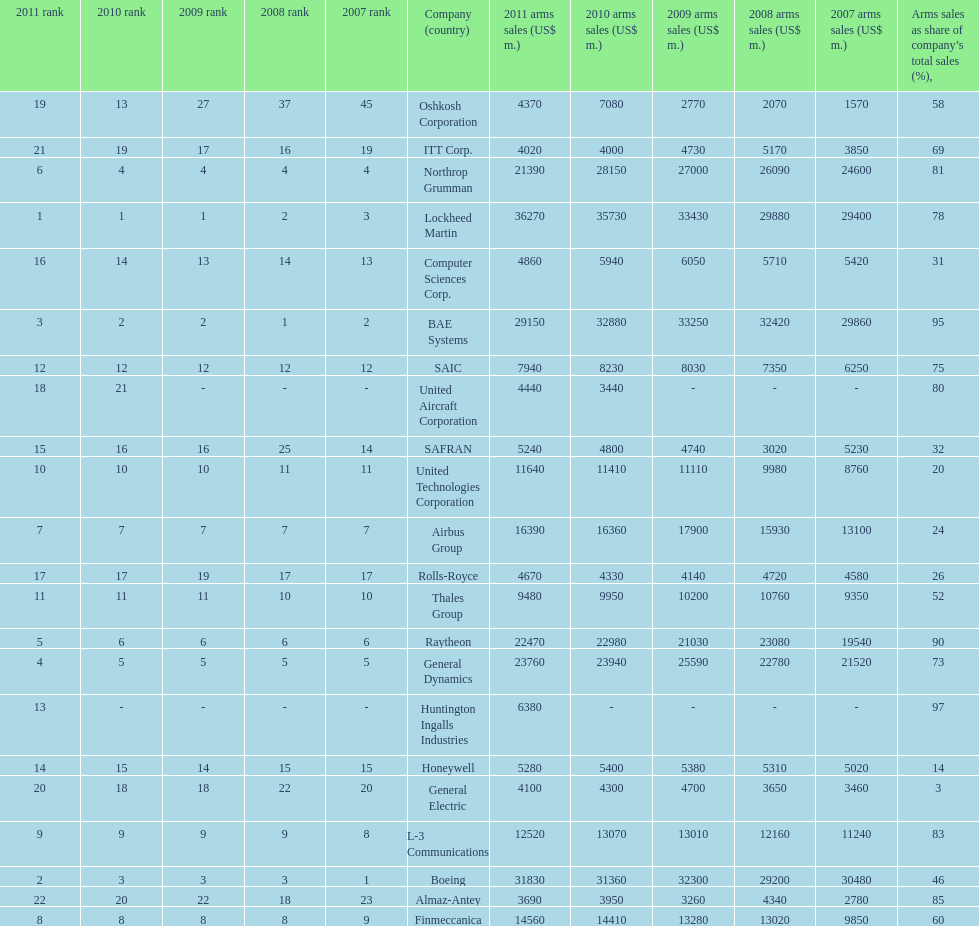What is the difference of the amount sold between boeing and general dynamics in 2007? 8960. 